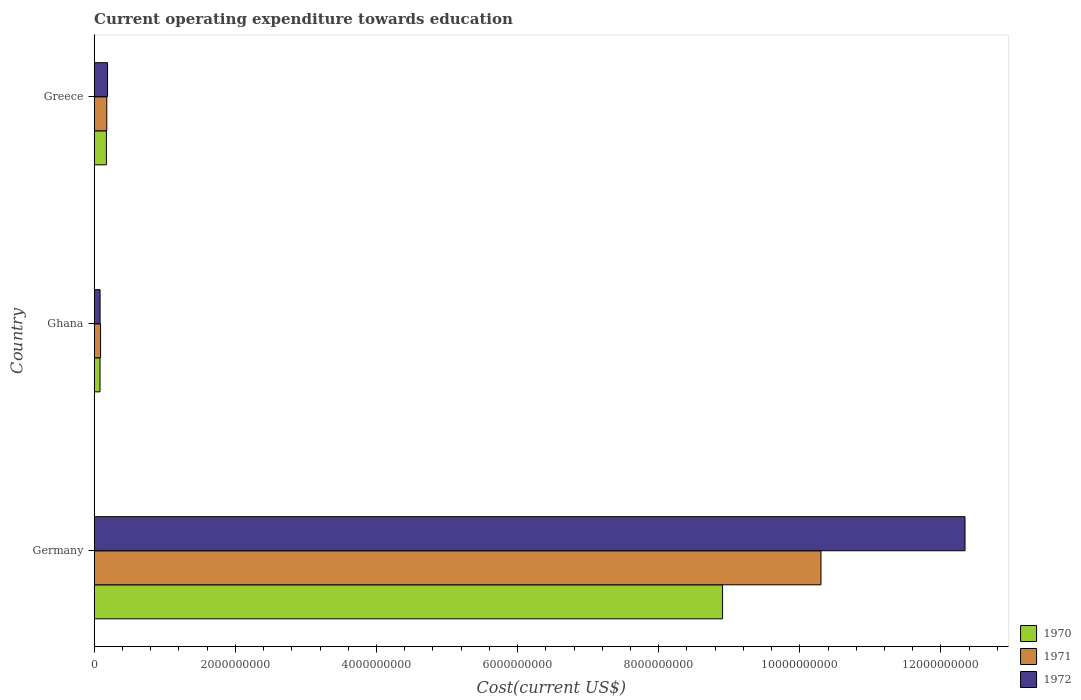How many different coloured bars are there?
Offer a very short reply. 3. Are the number of bars per tick equal to the number of legend labels?
Your response must be concise. Yes. Are the number of bars on each tick of the Y-axis equal?
Provide a short and direct response. Yes. How many bars are there on the 3rd tick from the top?
Make the answer very short. 3. What is the expenditure towards education in 1971 in Germany?
Provide a short and direct response. 1.03e+1. Across all countries, what is the maximum expenditure towards education in 1971?
Give a very brief answer. 1.03e+1. Across all countries, what is the minimum expenditure towards education in 1972?
Your answer should be compact. 8.34e+07. In which country was the expenditure towards education in 1971 maximum?
Provide a short and direct response. Germany. In which country was the expenditure towards education in 1971 minimum?
Provide a short and direct response. Ghana. What is the total expenditure towards education in 1970 in the graph?
Offer a very short reply. 9.16e+09. What is the difference between the expenditure towards education in 1970 in Germany and that in Ghana?
Offer a very short reply. 8.82e+09. What is the difference between the expenditure towards education in 1970 in Ghana and the expenditure towards education in 1971 in Germany?
Your response must be concise. -1.02e+1. What is the average expenditure towards education in 1972 per country?
Give a very brief answer. 4.20e+09. What is the difference between the expenditure towards education in 1970 and expenditure towards education in 1972 in Greece?
Your response must be concise. -1.61e+07. In how many countries, is the expenditure towards education in 1970 greater than 4800000000 US$?
Provide a short and direct response. 1. What is the ratio of the expenditure towards education in 1972 in Germany to that in Ghana?
Your response must be concise. 147.95. Is the difference between the expenditure towards education in 1970 in Germany and Greece greater than the difference between the expenditure towards education in 1972 in Germany and Greece?
Provide a short and direct response. No. What is the difference between the highest and the second highest expenditure towards education in 1972?
Keep it short and to the point. 1.22e+1. What is the difference between the highest and the lowest expenditure towards education in 1972?
Offer a terse response. 1.23e+1. In how many countries, is the expenditure towards education in 1972 greater than the average expenditure towards education in 1972 taken over all countries?
Provide a short and direct response. 1. How many bars are there?
Your answer should be very brief. 9. Are all the bars in the graph horizontal?
Offer a terse response. Yes. How are the legend labels stacked?
Provide a succinct answer. Vertical. What is the title of the graph?
Ensure brevity in your answer.  Current operating expenditure towards education. Does "1969" appear as one of the legend labels in the graph?
Your response must be concise. No. What is the label or title of the X-axis?
Your response must be concise. Cost(current US$). What is the Cost(current US$) of 1970 in Germany?
Offer a very short reply. 8.90e+09. What is the Cost(current US$) in 1971 in Germany?
Keep it short and to the point. 1.03e+1. What is the Cost(current US$) of 1972 in Germany?
Provide a succinct answer. 1.23e+1. What is the Cost(current US$) in 1970 in Ghana?
Keep it short and to the point. 8.25e+07. What is the Cost(current US$) of 1971 in Ghana?
Your response must be concise. 9.02e+07. What is the Cost(current US$) in 1972 in Ghana?
Provide a succinct answer. 8.34e+07. What is the Cost(current US$) in 1970 in Greece?
Make the answer very short. 1.73e+08. What is the Cost(current US$) in 1971 in Greece?
Offer a very short reply. 1.78e+08. What is the Cost(current US$) in 1972 in Greece?
Your response must be concise. 1.89e+08. Across all countries, what is the maximum Cost(current US$) in 1970?
Your response must be concise. 8.90e+09. Across all countries, what is the maximum Cost(current US$) of 1971?
Provide a short and direct response. 1.03e+1. Across all countries, what is the maximum Cost(current US$) in 1972?
Your answer should be compact. 1.23e+1. Across all countries, what is the minimum Cost(current US$) in 1970?
Offer a very short reply. 8.25e+07. Across all countries, what is the minimum Cost(current US$) in 1971?
Keep it short and to the point. 9.02e+07. Across all countries, what is the minimum Cost(current US$) of 1972?
Provide a succinct answer. 8.34e+07. What is the total Cost(current US$) in 1970 in the graph?
Offer a terse response. 9.16e+09. What is the total Cost(current US$) of 1971 in the graph?
Ensure brevity in your answer.  1.06e+1. What is the total Cost(current US$) of 1972 in the graph?
Offer a terse response. 1.26e+1. What is the difference between the Cost(current US$) in 1970 in Germany and that in Ghana?
Your answer should be very brief. 8.82e+09. What is the difference between the Cost(current US$) in 1971 in Germany and that in Ghana?
Provide a short and direct response. 1.02e+1. What is the difference between the Cost(current US$) in 1972 in Germany and that in Ghana?
Make the answer very short. 1.23e+1. What is the difference between the Cost(current US$) in 1970 in Germany and that in Greece?
Provide a succinct answer. 8.73e+09. What is the difference between the Cost(current US$) in 1971 in Germany and that in Greece?
Offer a very short reply. 1.01e+1. What is the difference between the Cost(current US$) of 1972 in Germany and that in Greece?
Provide a succinct answer. 1.22e+1. What is the difference between the Cost(current US$) in 1970 in Ghana and that in Greece?
Offer a very short reply. -9.05e+07. What is the difference between the Cost(current US$) of 1971 in Ghana and that in Greece?
Offer a terse response. -8.82e+07. What is the difference between the Cost(current US$) in 1972 in Ghana and that in Greece?
Ensure brevity in your answer.  -1.06e+08. What is the difference between the Cost(current US$) of 1970 in Germany and the Cost(current US$) of 1971 in Ghana?
Make the answer very short. 8.81e+09. What is the difference between the Cost(current US$) of 1970 in Germany and the Cost(current US$) of 1972 in Ghana?
Your answer should be very brief. 8.82e+09. What is the difference between the Cost(current US$) of 1971 in Germany and the Cost(current US$) of 1972 in Ghana?
Your response must be concise. 1.02e+1. What is the difference between the Cost(current US$) of 1970 in Germany and the Cost(current US$) of 1971 in Greece?
Ensure brevity in your answer.  8.73e+09. What is the difference between the Cost(current US$) of 1970 in Germany and the Cost(current US$) of 1972 in Greece?
Provide a succinct answer. 8.72e+09. What is the difference between the Cost(current US$) in 1971 in Germany and the Cost(current US$) in 1972 in Greece?
Provide a succinct answer. 1.01e+1. What is the difference between the Cost(current US$) of 1970 in Ghana and the Cost(current US$) of 1971 in Greece?
Your response must be concise. -9.59e+07. What is the difference between the Cost(current US$) of 1970 in Ghana and the Cost(current US$) of 1972 in Greece?
Ensure brevity in your answer.  -1.07e+08. What is the difference between the Cost(current US$) of 1971 in Ghana and the Cost(current US$) of 1972 in Greece?
Your response must be concise. -9.90e+07. What is the average Cost(current US$) of 1970 per country?
Keep it short and to the point. 3.05e+09. What is the average Cost(current US$) of 1971 per country?
Your answer should be very brief. 3.52e+09. What is the average Cost(current US$) of 1972 per country?
Your response must be concise. 4.20e+09. What is the difference between the Cost(current US$) in 1970 and Cost(current US$) in 1971 in Germany?
Offer a terse response. -1.39e+09. What is the difference between the Cost(current US$) in 1970 and Cost(current US$) in 1972 in Germany?
Give a very brief answer. -3.44e+09. What is the difference between the Cost(current US$) of 1971 and Cost(current US$) of 1972 in Germany?
Keep it short and to the point. -2.04e+09. What is the difference between the Cost(current US$) of 1970 and Cost(current US$) of 1971 in Ghana?
Provide a short and direct response. -7.67e+06. What is the difference between the Cost(current US$) of 1970 and Cost(current US$) of 1972 in Ghana?
Your answer should be compact. -9.19e+05. What is the difference between the Cost(current US$) of 1971 and Cost(current US$) of 1972 in Ghana?
Offer a terse response. 6.75e+06. What is the difference between the Cost(current US$) of 1970 and Cost(current US$) of 1971 in Greece?
Keep it short and to the point. -5.34e+06. What is the difference between the Cost(current US$) in 1970 and Cost(current US$) in 1972 in Greece?
Offer a terse response. -1.61e+07. What is the difference between the Cost(current US$) of 1971 and Cost(current US$) of 1972 in Greece?
Provide a succinct answer. -1.07e+07. What is the ratio of the Cost(current US$) of 1970 in Germany to that in Ghana?
Make the answer very short. 107.95. What is the ratio of the Cost(current US$) in 1971 in Germany to that in Ghana?
Ensure brevity in your answer.  114.24. What is the ratio of the Cost(current US$) in 1972 in Germany to that in Ghana?
Your answer should be compact. 147.95. What is the ratio of the Cost(current US$) in 1970 in Germany to that in Greece?
Your answer should be compact. 51.46. What is the ratio of the Cost(current US$) in 1971 in Germany to that in Greece?
Your answer should be very brief. 57.74. What is the ratio of the Cost(current US$) of 1972 in Germany to that in Greece?
Offer a very short reply. 65.25. What is the ratio of the Cost(current US$) in 1970 in Ghana to that in Greece?
Keep it short and to the point. 0.48. What is the ratio of the Cost(current US$) of 1971 in Ghana to that in Greece?
Offer a terse response. 0.51. What is the ratio of the Cost(current US$) of 1972 in Ghana to that in Greece?
Offer a very short reply. 0.44. What is the difference between the highest and the second highest Cost(current US$) in 1970?
Your response must be concise. 8.73e+09. What is the difference between the highest and the second highest Cost(current US$) of 1971?
Your response must be concise. 1.01e+1. What is the difference between the highest and the second highest Cost(current US$) of 1972?
Ensure brevity in your answer.  1.22e+1. What is the difference between the highest and the lowest Cost(current US$) of 1970?
Make the answer very short. 8.82e+09. What is the difference between the highest and the lowest Cost(current US$) of 1971?
Your answer should be very brief. 1.02e+1. What is the difference between the highest and the lowest Cost(current US$) in 1972?
Give a very brief answer. 1.23e+1. 